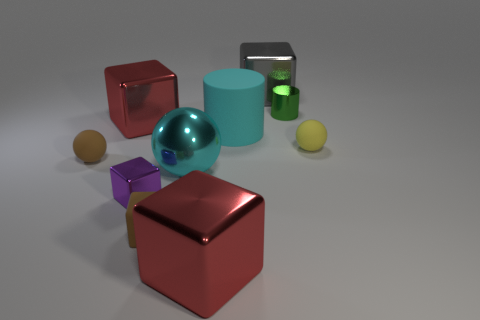Subtract all brown cubes. How many cubes are left? 4 Subtract all tiny brown matte cubes. How many cubes are left? 4 Subtract all yellow cubes. Subtract all blue balls. How many cubes are left? 5 Subtract all balls. How many objects are left? 7 Subtract 1 red blocks. How many objects are left? 9 Subtract all small cylinders. Subtract all metallic things. How many objects are left? 3 Add 3 big cyan matte things. How many big cyan matte things are left? 4 Add 4 brown rubber blocks. How many brown rubber blocks exist? 5 